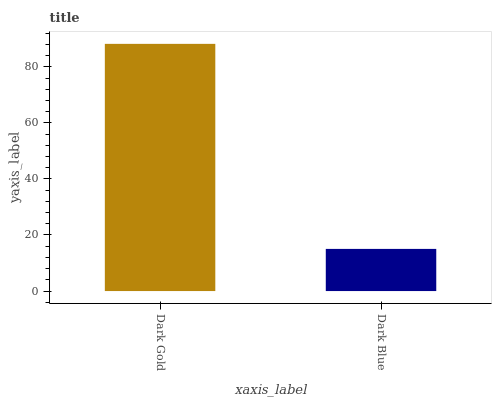Is Dark Blue the minimum?
Answer yes or no. Yes. Is Dark Gold the maximum?
Answer yes or no. Yes. Is Dark Blue the maximum?
Answer yes or no. No. Is Dark Gold greater than Dark Blue?
Answer yes or no. Yes. Is Dark Blue less than Dark Gold?
Answer yes or no. Yes. Is Dark Blue greater than Dark Gold?
Answer yes or no. No. Is Dark Gold less than Dark Blue?
Answer yes or no. No. Is Dark Gold the high median?
Answer yes or no. Yes. Is Dark Blue the low median?
Answer yes or no. Yes. Is Dark Blue the high median?
Answer yes or no. No. Is Dark Gold the low median?
Answer yes or no. No. 